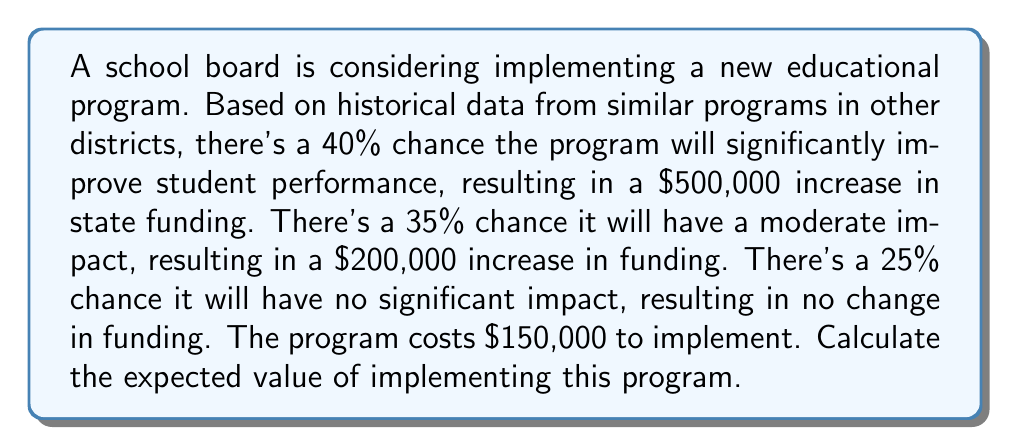Provide a solution to this math problem. Let's approach this step-by-step:

1) First, we need to calculate the expected value of the funding increase:

   a) Significant improvement: 
      $$0.40 \times \$500,000 = \$200,000$$
   
   b) Moderate impact:
      $$0.35 \times \$200,000 = \$70,000$$
   
   c) No significant impact:
      $$0.25 \times \$0 = \$0$$

2) The total expected value of the funding increase is the sum of these:
   $$\$200,000 + \$70,000 + \$0 = \$270,000$$

3) However, we need to subtract the cost of implementing the program:
   $$\$270,000 - \$150,000 = \$120,000$$

4) Therefore, the expected value of implementing the program is $120,000.

This can be expressed mathematically as:

$$E = (0.40 \times 500000 + 0.35 \times 200000 + 0.25 \times 0) - 150000 = 120000$$

Where $E$ is the expected value.
Answer: $120,000 